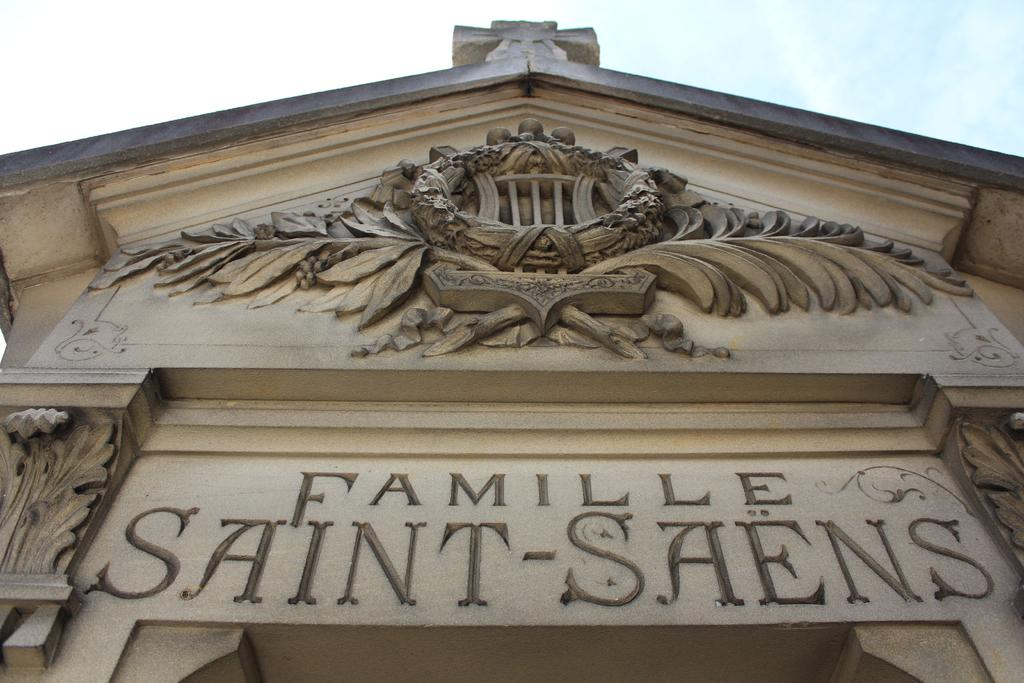What type of structure is present in the image? There is a building in the image. Can you describe the color of the building? The building is in cream color. What else can be seen in the image besides the building? The sky is visible in the image. How would you describe the color of the sky in the image? The sky is in white color. Where is the boot located in the image? There is no boot present in the image. What type of trail can be seen in the image? There is no trail present in the image. 